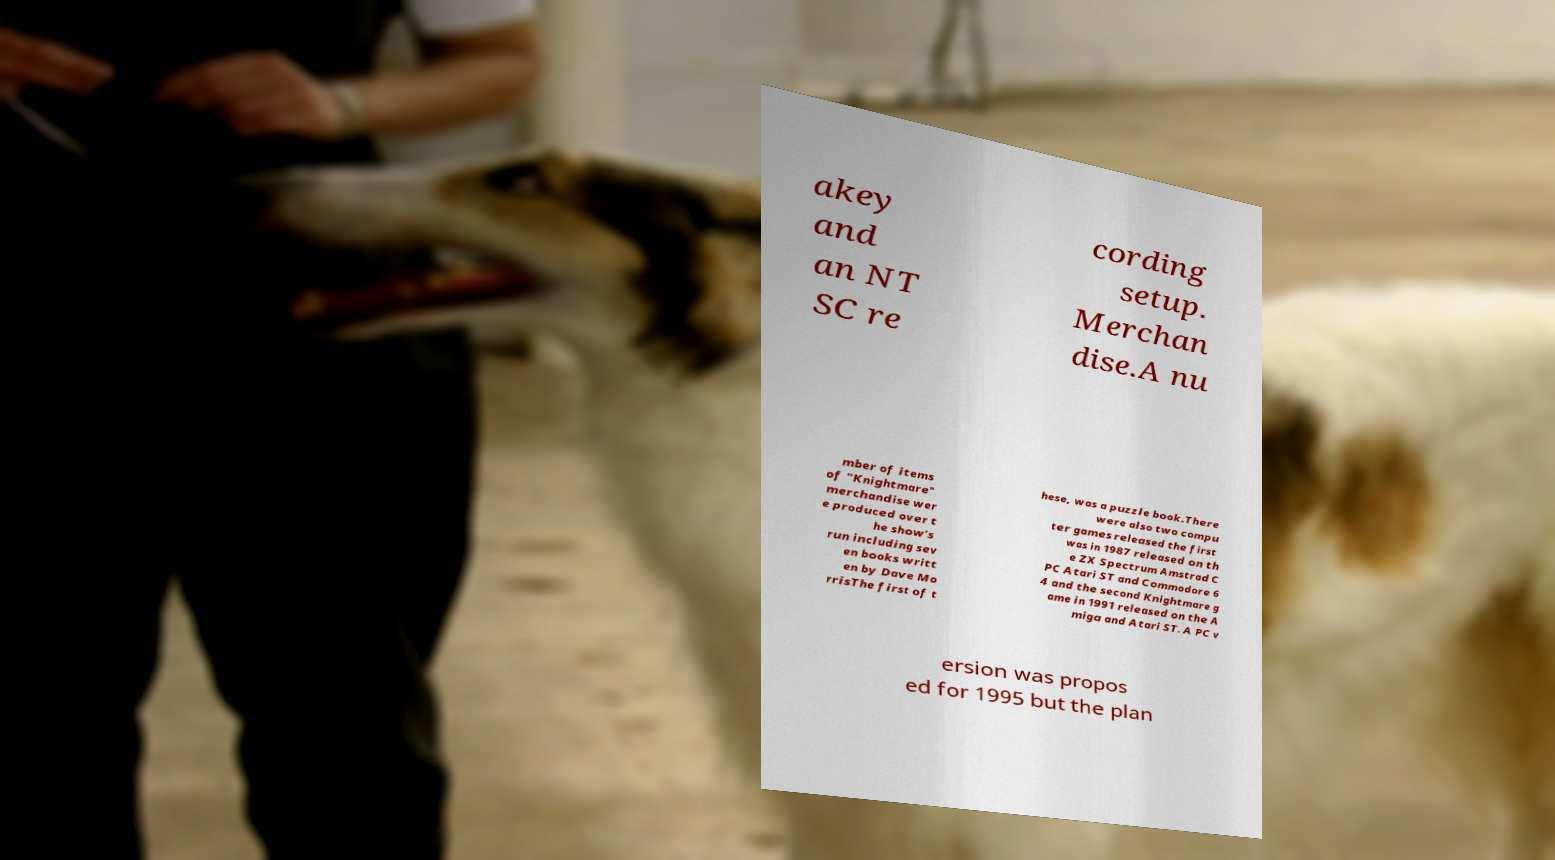I need the written content from this picture converted into text. Can you do that? akey and an NT SC re cording setup. Merchan dise.A nu mber of items of "Knightmare" merchandise wer e produced over t he show's run including sev en books writt en by Dave Mo rrisThe first of t hese, was a puzzle book.There were also two compu ter games released the first was in 1987 released on th e ZX Spectrum Amstrad C PC Atari ST and Commodore 6 4 and the second Knightmare g ame in 1991 released on the A miga and Atari ST. A PC v ersion was propos ed for 1995 but the plan 